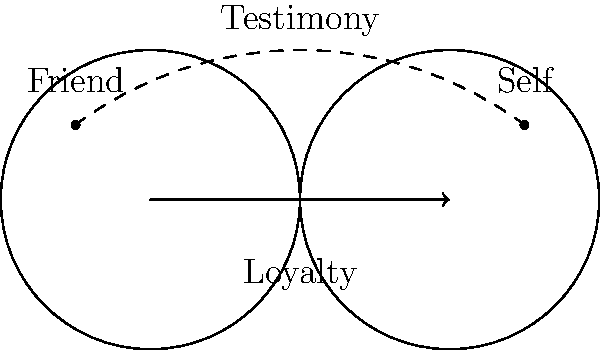Consider the Möbius strip representation of friendship loyalty shown in the diagram. If the continuous path from "Friend" to "Self" represents the journey of testimony, how many full rotations would this path make around the Möbius strip before reaching the "Self" point? To solve this problem, we need to understand the properties of a Möbius strip and how it relates to the complexity of loyalties in friendships:

1. A Möbius strip is a surface with only one side and one boundary component.

2. In this representation, the strip symbolizes the continuum of loyalty between the friend and self.

3. The dashed line represents the path of testimony from "Friend" to "Self".

4. On a Möbius strip, a path that starts on one "side" and travels the full length will end up on the opposite "side" at the same point.

5. To complete one full rotation and return to the same "side", the path needs to travel the length of the strip twice.

6. In this case, the path goes from "Friend" to "Self" directly, which is equivalent to traveling the length of the strip once.

7. Therefore, the path makes half a rotation around the Möbius strip.

This representation illustrates the conflicting nature of testifying against a friend, as the path of testimony traverses the complex, intertwined nature of loyalty represented by the Möbius strip.
Answer: $\frac{1}{2}$ rotation 